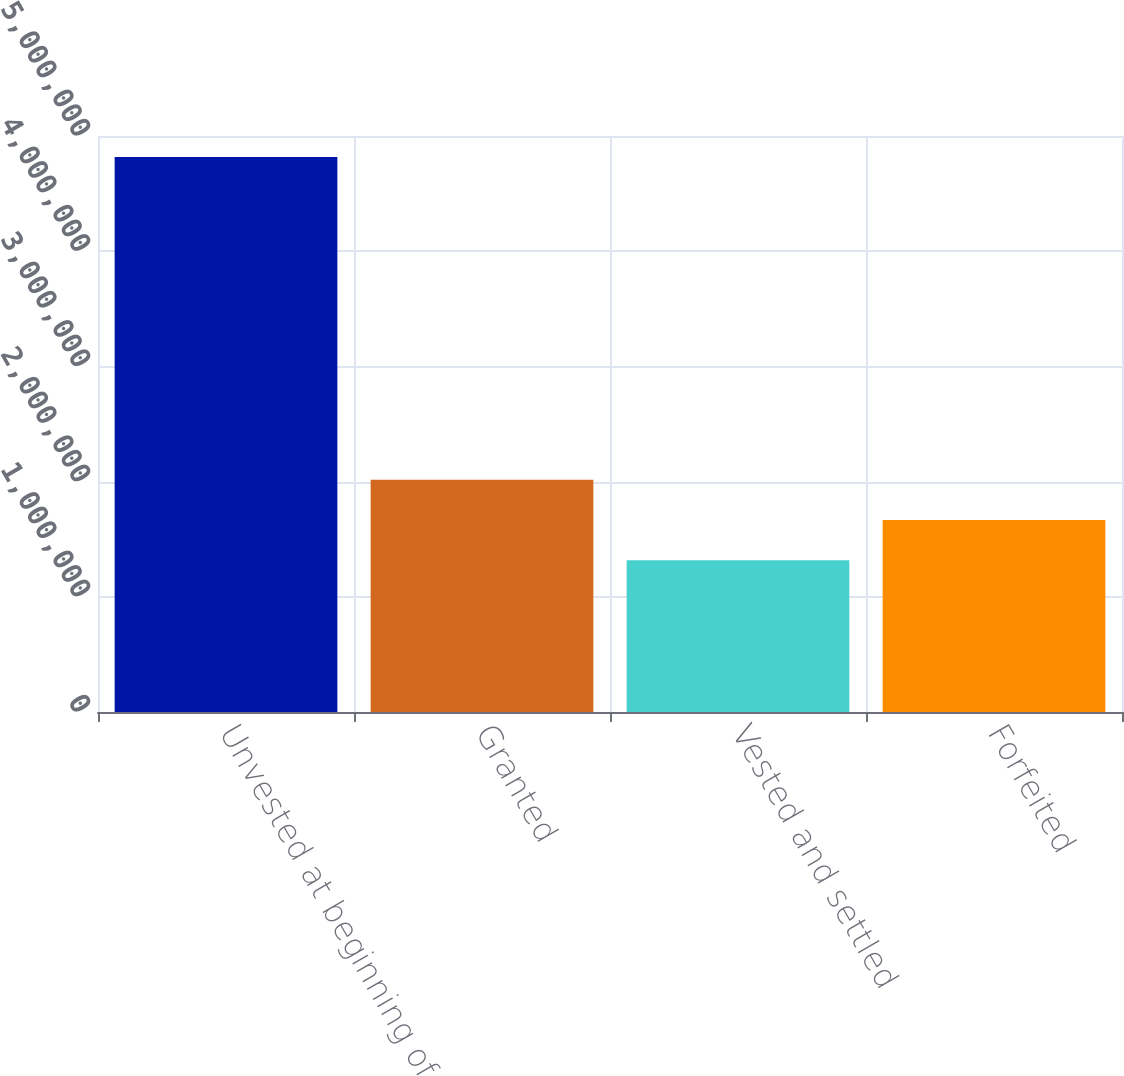<chart> <loc_0><loc_0><loc_500><loc_500><bar_chart><fcel>Unvested at beginning of<fcel>Granted<fcel>Vested and settled<fcel>Forfeited<nl><fcel>4.81686e+06<fcel>2.01651e+06<fcel>1.31643e+06<fcel>1.66647e+06<nl></chart> 